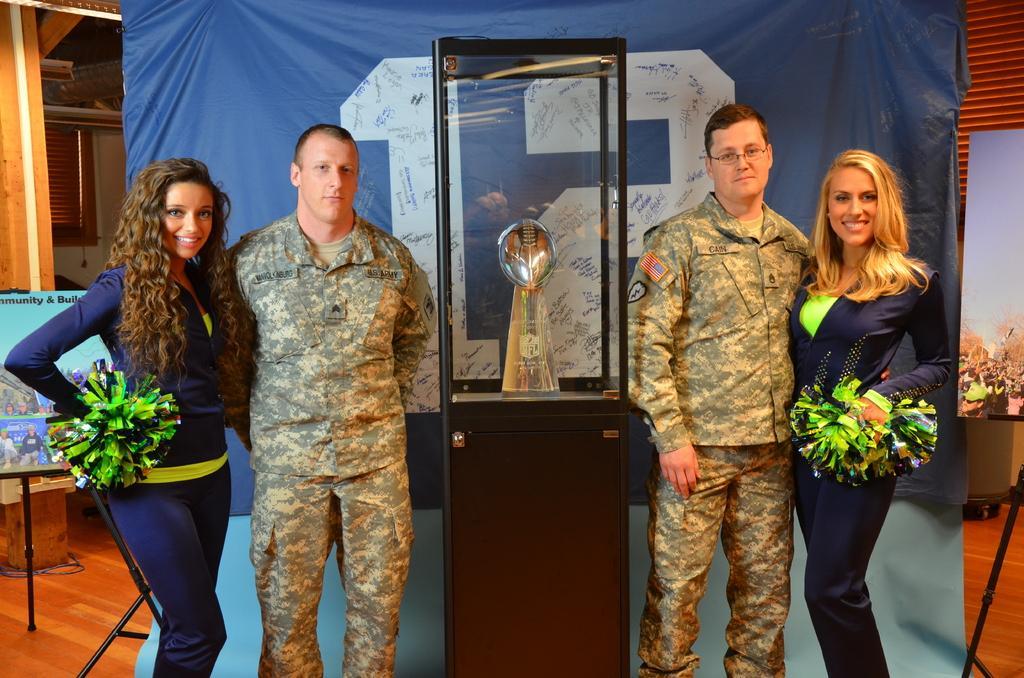How would you summarize this image in a sentence or two? The picture is taken in a room. On the right there is a man and a woman standing. On the left there is a man and a woman standing. In the center there is a trophy. Behind them there is a banner. In the background it is well. On the left there is a hoarding, on the stand. On the right there is another hoarding, on the stand. 